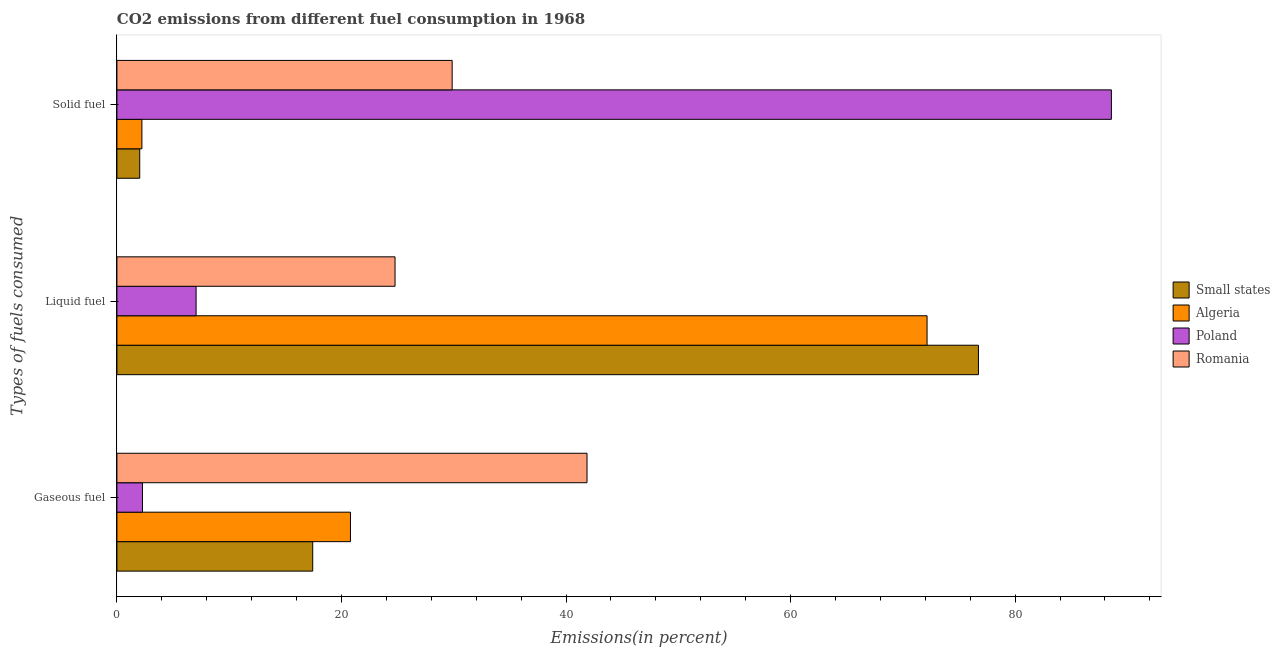How many different coloured bars are there?
Keep it short and to the point. 4. How many groups of bars are there?
Offer a very short reply. 3. Are the number of bars per tick equal to the number of legend labels?
Offer a terse response. Yes. Are the number of bars on each tick of the Y-axis equal?
Provide a succinct answer. Yes. How many bars are there on the 1st tick from the top?
Offer a terse response. 4. How many bars are there on the 3rd tick from the bottom?
Your answer should be very brief. 4. What is the label of the 1st group of bars from the top?
Give a very brief answer. Solid fuel. What is the percentage of gaseous fuel emission in Small states?
Keep it short and to the point. 17.44. Across all countries, what is the maximum percentage of solid fuel emission?
Give a very brief answer. 88.58. Across all countries, what is the minimum percentage of gaseous fuel emission?
Make the answer very short. 2.28. In which country was the percentage of gaseous fuel emission maximum?
Your answer should be compact. Romania. In which country was the percentage of gaseous fuel emission minimum?
Your answer should be compact. Poland. What is the total percentage of solid fuel emission in the graph?
Your answer should be very brief. 122.69. What is the difference between the percentage of gaseous fuel emission in Small states and that in Algeria?
Ensure brevity in your answer.  -3.36. What is the difference between the percentage of liquid fuel emission in Small states and the percentage of solid fuel emission in Romania?
Offer a very short reply. 46.87. What is the average percentage of liquid fuel emission per country?
Offer a very short reply. 45.18. What is the difference between the percentage of gaseous fuel emission and percentage of liquid fuel emission in Poland?
Give a very brief answer. -4.78. In how many countries, is the percentage of gaseous fuel emission greater than 80 %?
Give a very brief answer. 0. What is the ratio of the percentage of gaseous fuel emission in Poland to that in Small states?
Offer a very short reply. 0.13. What is the difference between the highest and the second highest percentage of solid fuel emission?
Your answer should be very brief. 58.72. What is the difference between the highest and the lowest percentage of liquid fuel emission?
Keep it short and to the point. 69.68. What does the 4th bar from the top in Gaseous fuel represents?
Offer a terse response. Small states. What does the 4th bar from the bottom in Liquid fuel represents?
Make the answer very short. Romania. How many countries are there in the graph?
Your response must be concise. 4. Does the graph contain any zero values?
Give a very brief answer. No. Where does the legend appear in the graph?
Ensure brevity in your answer.  Center right. What is the title of the graph?
Offer a terse response. CO2 emissions from different fuel consumption in 1968. Does "Nigeria" appear as one of the legend labels in the graph?
Provide a short and direct response. No. What is the label or title of the X-axis?
Your response must be concise. Emissions(in percent). What is the label or title of the Y-axis?
Offer a very short reply. Types of fuels consumed. What is the Emissions(in percent) of Small states in Gaseous fuel?
Offer a terse response. 17.44. What is the Emissions(in percent) in Algeria in Gaseous fuel?
Offer a very short reply. 20.8. What is the Emissions(in percent) in Poland in Gaseous fuel?
Offer a terse response. 2.28. What is the Emissions(in percent) in Romania in Gaseous fuel?
Provide a short and direct response. 41.87. What is the Emissions(in percent) in Small states in Liquid fuel?
Offer a terse response. 76.73. What is the Emissions(in percent) in Algeria in Liquid fuel?
Ensure brevity in your answer.  72.16. What is the Emissions(in percent) of Poland in Liquid fuel?
Your answer should be compact. 7.05. What is the Emissions(in percent) in Romania in Liquid fuel?
Offer a very short reply. 24.77. What is the Emissions(in percent) in Small states in Solid fuel?
Provide a short and direct response. 2.03. What is the Emissions(in percent) of Algeria in Solid fuel?
Make the answer very short. 2.23. What is the Emissions(in percent) in Poland in Solid fuel?
Offer a terse response. 88.58. What is the Emissions(in percent) in Romania in Solid fuel?
Ensure brevity in your answer.  29.86. Across all Types of fuels consumed, what is the maximum Emissions(in percent) in Small states?
Ensure brevity in your answer.  76.73. Across all Types of fuels consumed, what is the maximum Emissions(in percent) of Algeria?
Your answer should be compact. 72.16. Across all Types of fuels consumed, what is the maximum Emissions(in percent) of Poland?
Give a very brief answer. 88.58. Across all Types of fuels consumed, what is the maximum Emissions(in percent) of Romania?
Provide a short and direct response. 41.87. Across all Types of fuels consumed, what is the minimum Emissions(in percent) of Small states?
Give a very brief answer. 2.03. Across all Types of fuels consumed, what is the minimum Emissions(in percent) in Algeria?
Offer a terse response. 2.23. Across all Types of fuels consumed, what is the minimum Emissions(in percent) of Poland?
Give a very brief answer. 2.28. Across all Types of fuels consumed, what is the minimum Emissions(in percent) in Romania?
Offer a terse response. 24.77. What is the total Emissions(in percent) in Small states in the graph?
Offer a terse response. 96.2. What is the total Emissions(in percent) of Algeria in the graph?
Ensure brevity in your answer.  95.18. What is the total Emissions(in percent) in Poland in the graph?
Your response must be concise. 97.9. What is the total Emissions(in percent) of Romania in the graph?
Offer a very short reply. 96.5. What is the difference between the Emissions(in percent) of Small states in Gaseous fuel and that in Liquid fuel?
Your answer should be very brief. -59.29. What is the difference between the Emissions(in percent) of Algeria in Gaseous fuel and that in Liquid fuel?
Your answer should be very brief. -51.36. What is the difference between the Emissions(in percent) in Poland in Gaseous fuel and that in Liquid fuel?
Give a very brief answer. -4.78. What is the difference between the Emissions(in percent) in Romania in Gaseous fuel and that in Liquid fuel?
Your answer should be very brief. 17.1. What is the difference between the Emissions(in percent) in Small states in Gaseous fuel and that in Solid fuel?
Your answer should be very brief. 15.41. What is the difference between the Emissions(in percent) of Algeria in Gaseous fuel and that in Solid fuel?
Offer a very short reply. 18.58. What is the difference between the Emissions(in percent) of Poland in Gaseous fuel and that in Solid fuel?
Ensure brevity in your answer.  -86.3. What is the difference between the Emissions(in percent) in Romania in Gaseous fuel and that in Solid fuel?
Offer a terse response. 12.01. What is the difference between the Emissions(in percent) of Small states in Liquid fuel and that in Solid fuel?
Offer a very short reply. 74.7. What is the difference between the Emissions(in percent) in Algeria in Liquid fuel and that in Solid fuel?
Offer a very short reply. 69.93. What is the difference between the Emissions(in percent) of Poland in Liquid fuel and that in Solid fuel?
Keep it short and to the point. -81.52. What is the difference between the Emissions(in percent) in Romania in Liquid fuel and that in Solid fuel?
Your response must be concise. -5.09. What is the difference between the Emissions(in percent) of Small states in Gaseous fuel and the Emissions(in percent) of Algeria in Liquid fuel?
Your answer should be very brief. -54.72. What is the difference between the Emissions(in percent) in Small states in Gaseous fuel and the Emissions(in percent) in Poland in Liquid fuel?
Make the answer very short. 10.39. What is the difference between the Emissions(in percent) of Small states in Gaseous fuel and the Emissions(in percent) of Romania in Liquid fuel?
Your answer should be very brief. -7.33. What is the difference between the Emissions(in percent) in Algeria in Gaseous fuel and the Emissions(in percent) in Poland in Liquid fuel?
Offer a terse response. 13.75. What is the difference between the Emissions(in percent) of Algeria in Gaseous fuel and the Emissions(in percent) of Romania in Liquid fuel?
Give a very brief answer. -3.97. What is the difference between the Emissions(in percent) in Poland in Gaseous fuel and the Emissions(in percent) in Romania in Liquid fuel?
Ensure brevity in your answer.  -22.5. What is the difference between the Emissions(in percent) in Small states in Gaseous fuel and the Emissions(in percent) in Algeria in Solid fuel?
Your response must be concise. 15.21. What is the difference between the Emissions(in percent) in Small states in Gaseous fuel and the Emissions(in percent) in Poland in Solid fuel?
Keep it short and to the point. -71.14. What is the difference between the Emissions(in percent) in Small states in Gaseous fuel and the Emissions(in percent) in Romania in Solid fuel?
Offer a terse response. -12.42. What is the difference between the Emissions(in percent) in Algeria in Gaseous fuel and the Emissions(in percent) in Poland in Solid fuel?
Make the answer very short. -67.77. What is the difference between the Emissions(in percent) in Algeria in Gaseous fuel and the Emissions(in percent) in Romania in Solid fuel?
Keep it short and to the point. -9.06. What is the difference between the Emissions(in percent) in Poland in Gaseous fuel and the Emissions(in percent) in Romania in Solid fuel?
Provide a succinct answer. -27.58. What is the difference between the Emissions(in percent) of Small states in Liquid fuel and the Emissions(in percent) of Algeria in Solid fuel?
Ensure brevity in your answer.  74.51. What is the difference between the Emissions(in percent) in Small states in Liquid fuel and the Emissions(in percent) in Poland in Solid fuel?
Ensure brevity in your answer.  -11.84. What is the difference between the Emissions(in percent) of Small states in Liquid fuel and the Emissions(in percent) of Romania in Solid fuel?
Offer a very short reply. 46.88. What is the difference between the Emissions(in percent) of Algeria in Liquid fuel and the Emissions(in percent) of Poland in Solid fuel?
Offer a terse response. -16.42. What is the difference between the Emissions(in percent) of Algeria in Liquid fuel and the Emissions(in percent) of Romania in Solid fuel?
Ensure brevity in your answer.  42.3. What is the difference between the Emissions(in percent) in Poland in Liquid fuel and the Emissions(in percent) in Romania in Solid fuel?
Offer a very short reply. -22.81. What is the average Emissions(in percent) of Small states per Types of fuels consumed?
Provide a succinct answer. 32.07. What is the average Emissions(in percent) of Algeria per Types of fuels consumed?
Provide a short and direct response. 31.73. What is the average Emissions(in percent) of Poland per Types of fuels consumed?
Offer a very short reply. 32.63. What is the average Emissions(in percent) of Romania per Types of fuels consumed?
Provide a succinct answer. 32.17. What is the difference between the Emissions(in percent) of Small states and Emissions(in percent) of Algeria in Gaseous fuel?
Your answer should be very brief. -3.36. What is the difference between the Emissions(in percent) of Small states and Emissions(in percent) of Poland in Gaseous fuel?
Make the answer very short. 15.16. What is the difference between the Emissions(in percent) in Small states and Emissions(in percent) in Romania in Gaseous fuel?
Your response must be concise. -24.43. What is the difference between the Emissions(in percent) in Algeria and Emissions(in percent) in Poland in Gaseous fuel?
Keep it short and to the point. 18.53. What is the difference between the Emissions(in percent) of Algeria and Emissions(in percent) of Romania in Gaseous fuel?
Your answer should be very brief. -21.07. What is the difference between the Emissions(in percent) in Poland and Emissions(in percent) in Romania in Gaseous fuel?
Offer a very short reply. -39.6. What is the difference between the Emissions(in percent) of Small states and Emissions(in percent) of Algeria in Liquid fuel?
Your answer should be very brief. 4.58. What is the difference between the Emissions(in percent) of Small states and Emissions(in percent) of Poland in Liquid fuel?
Your response must be concise. 69.68. What is the difference between the Emissions(in percent) of Small states and Emissions(in percent) of Romania in Liquid fuel?
Provide a short and direct response. 51.96. What is the difference between the Emissions(in percent) of Algeria and Emissions(in percent) of Poland in Liquid fuel?
Your response must be concise. 65.11. What is the difference between the Emissions(in percent) of Algeria and Emissions(in percent) of Romania in Liquid fuel?
Provide a short and direct response. 47.39. What is the difference between the Emissions(in percent) in Poland and Emissions(in percent) in Romania in Liquid fuel?
Your answer should be compact. -17.72. What is the difference between the Emissions(in percent) of Small states and Emissions(in percent) of Algeria in Solid fuel?
Provide a succinct answer. -0.19. What is the difference between the Emissions(in percent) in Small states and Emissions(in percent) in Poland in Solid fuel?
Your answer should be very brief. -86.54. What is the difference between the Emissions(in percent) of Small states and Emissions(in percent) of Romania in Solid fuel?
Provide a short and direct response. -27.83. What is the difference between the Emissions(in percent) of Algeria and Emissions(in percent) of Poland in Solid fuel?
Give a very brief answer. -86.35. What is the difference between the Emissions(in percent) in Algeria and Emissions(in percent) in Romania in Solid fuel?
Your answer should be very brief. -27.63. What is the difference between the Emissions(in percent) of Poland and Emissions(in percent) of Romania in Solid fuel?
Your response must be concise. 58.72. What is the ratio of the Emissions(in percent) of Small states in Gaseous fuel to that in Liquid fuel?
Ensure brevity in your answer.  0.23. What is the ratio of the Emissions(in percent) of Algeria in Gaseous fuel to that in Liquid fuel?
Your response must be concise. 0.29. What is the ratio of the Emissions(in percent) in Poland in Gaseous fuel to that in Liquid fuel?
Offer a terse response. 0.32. What is the ratio of the Emissions(in percent) of Romania in Gaseous fuel to that in Liquid fuel?
Your answer should be compact. 1.69. What is the ratio of the Emissions(in percent) of Small states in Gaseous fuel to that in Solid fuel?
Your answer should be very brief. 8.59. What is the ratio of the Emissions(in percent) of Algeria in Gaseous fuel to that in Solid fuel?
Your answer should be very brief. 9.35. What is the ratio of the Emissions(in percent) in Poland in Gaseous fuel to that in Solid fuel?
Offer a very short reply. 0.03. What is the ratio of the Emissions(in percent) in Romania in Gaseous fuel to that in Solid fuel?
Make the answer very short. 1.4. What is the ratio of the Emissions(in percent) of Small states in Liquid fuel to that in Solid fuel?
Give a very brief answer. 37.78. What is the ratio of the Emissions(in percent) of Algeria in Liquid fuel to that in Solid fuel?
Make the answer very short. 32.42. What is the ratio of the Emissions(in percent) in Poland in Liquid fuel to that in Solid fuel?
Provide a short and direct response. 0.08. What is the ratio of the Emissions(in percent) in Romania in Liquid fuel to that in Solid fuel?
Offer a terse response. 0.83. What is the difference between the highest and the second highest Emissions(in percent) in Small states?
Offer a very short reply. 59.29. What is the difference between the highest and the second highest Emissions(in percent) in Algeria?
Your answer should be compact. 51.36. What is the difference between the highest and the second highest Emissions(in percent) in Poland?
Provide a short and direct response. 81.52. What is the difference between the highest and the second highest Emissions(in percent) of Romania?
Your response must be concise. 12.01. What is the difference between the highest and the lowest Emissions(in percent) in Small states?
Provide a short and direct response. 74.7. What is the difference between the highest and the lowest Emissions(in percent) of Algeria?
Ensure brevity in your answer.  69.93. What is the difference between the highest and the lowest Emissions(in percent) in Poland?
Your answer should be very brief. 86.3. What is the difference between the highest and the lowest Emissions(in percent) in Romania?
Give a very brief answer. 17.1. 